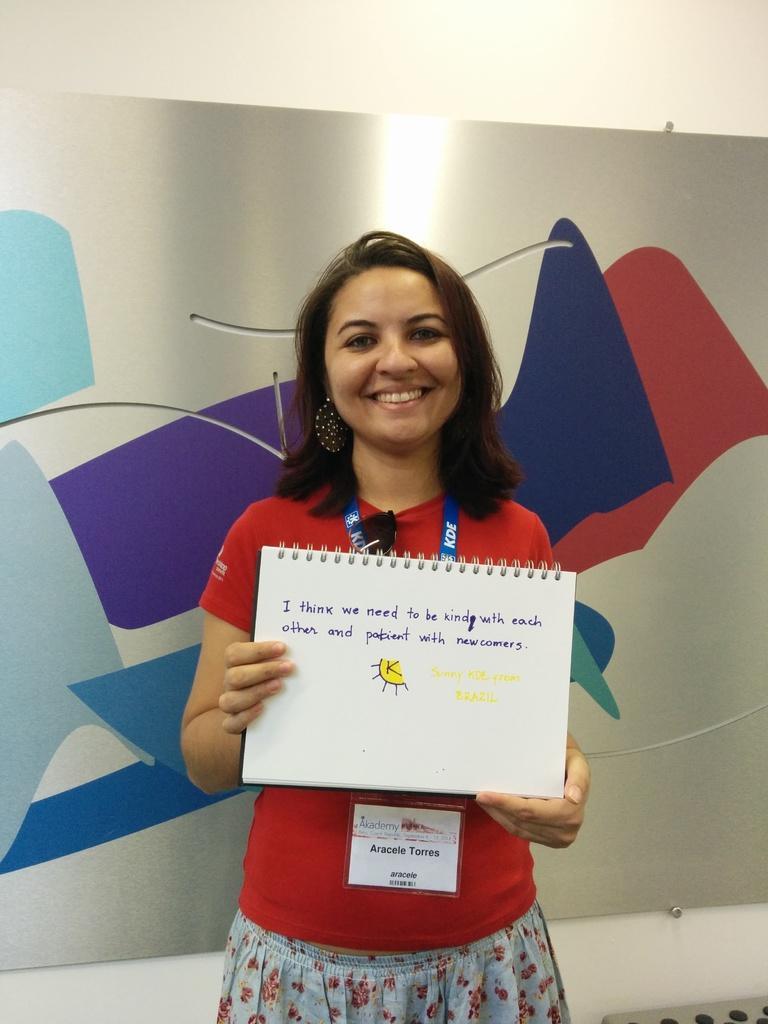How would you summarize this image in a sentence or two? In the picture I can see a woman standing and holding a book which has something written on it and there are few other objects in the background. 